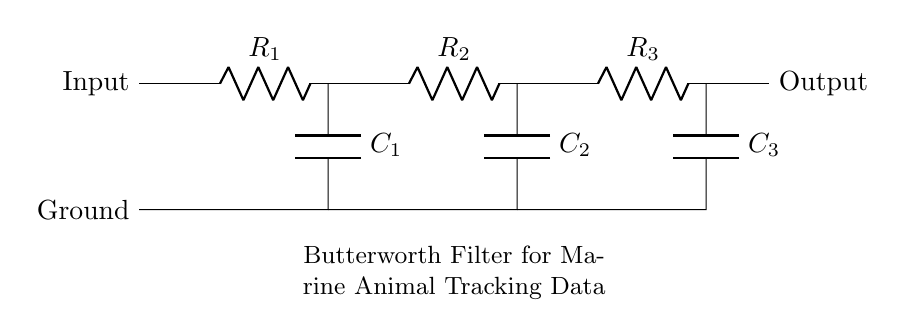What is the total number of resistors in the circuit? There are three resistors labeled R1, R2, and R3 in the circuit diagram.
Answer: Three What is the total number of capacitors in the circuit? The circuit consists of three capacitors, indicated as C1, C2, and C3.
Answer: Three Which component connects the input to the first resistor? The connection is made through a short wire that leads directly from the input to the first resistor (R1) in the circuit.
Answer: Short wire How are the capacitors configured in this Butterworth filter? The capacitors (C1, C2, C3) are arranged in parallel with respect to their respective connected resistors, which allows them to collectively filter the signal smoothly.
Answer: In parallel What is the purpose of the Butterworth filter in this context? The Butterworth filter is designed to smooth the data from marine animal tracking devices, reducing noise and allowing for more accurate readings of animal movements.
Answer: Smoothing data Could you determine the cutoff frequency just from the component values seen here? No, the cutoff frequency depends on the values of the resistors and capacitors, which are not specified in the diagram. Thus, additional information is needed to calculate it accurately.
Answer: No What defines this circuit as a Butterworth filter specifically? A Butterworth filter is characterized by having a maximally flat frequency response in the passband, which this circuit achieves by the specific arrangement of resistors and capacitors.
Answer: Maximally flat response 